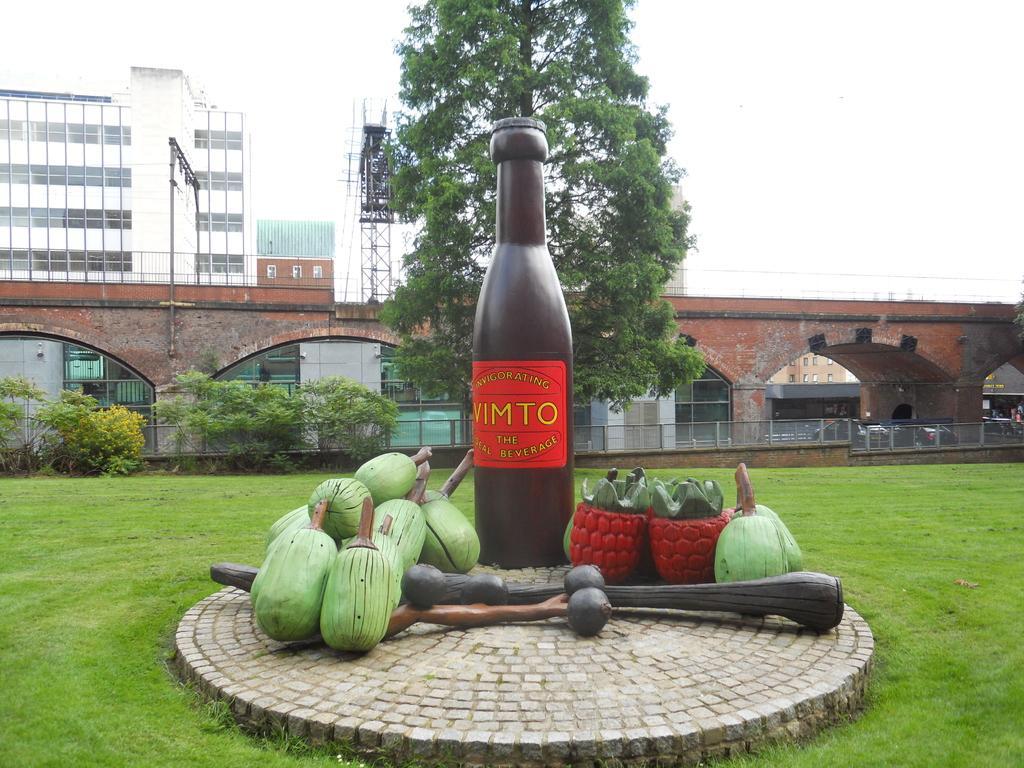In one or two sentences, can you explain what this image depicts? This picture is clicked outside. In the center we can see the sculpture of a bottle and there are some objects placed on the ground and we can see the ground is covered with the green grass. In the center we can see the plants, railings and the buildings and some metal rods and a tree. In the background there is a sky and we can see the buildings. 